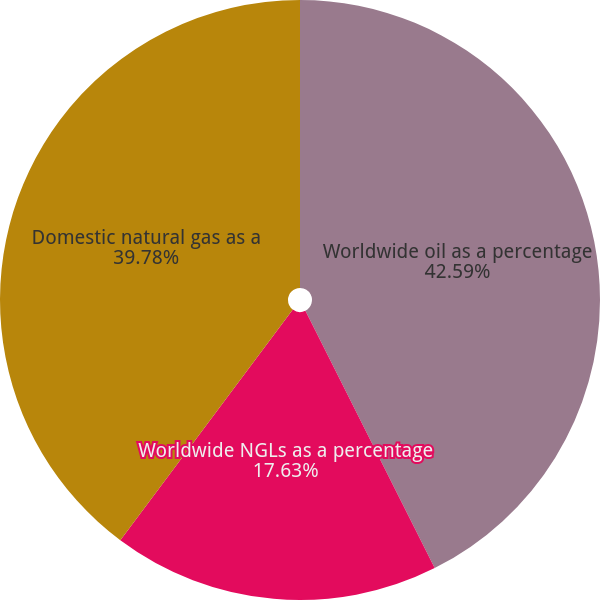Convert chart to OTSL. <chart><loc_0><loc_0><loc_500><loc_500><pie_chart><fcel>Worldwide oil as a percentage<fcel>Worldwide NGLs as a percentage<fcel>Domestic natural gas as a<nl><fcel>42.59%<fcel>17.63%<fcel>39.78%<nl></chart> 